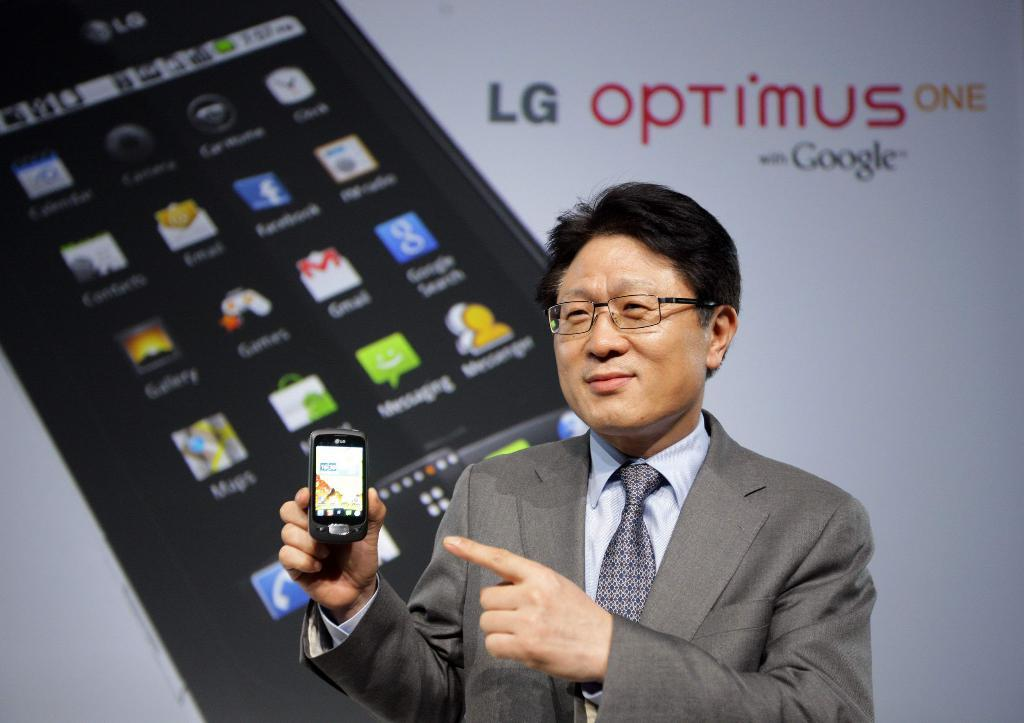Provide a one-sentence caption for the provided image. a man with an LG optimus phone in his hand. 